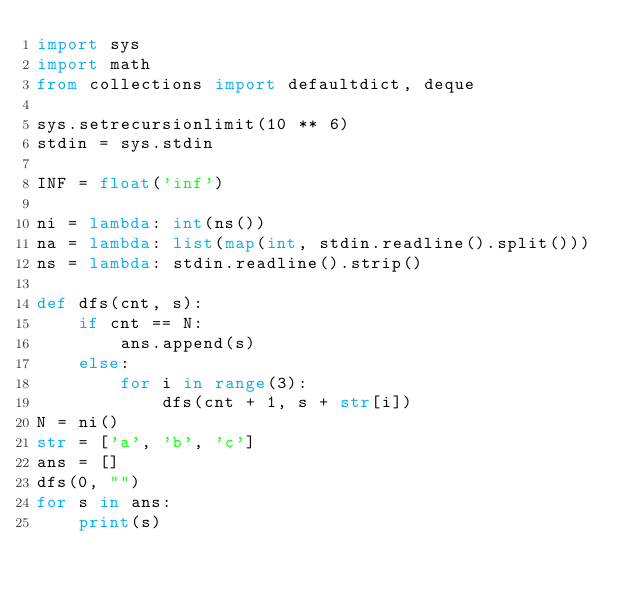Convert code to text. <code><loc_0><loc_0><loc_500><loc_500><_Python_>import sys
import math
from collections import defaultdict, deque

sys.setrecursionlimit(10 ** 6)
stdin = sys.stdin

INF = float('inf')

ni = lambda: int(ns())
na = lambda: list(map(int, stdin.readline().split()))
ns = lambda: stdin.readline().strip()

def dfs(cnt, s):
    if cnt == N:
        ans.append(s)
    else:
        for i in range(3):
            dfs(cnt + 1, s + str[i])
N = ni()
str = ['a', 'b', 'c']
ans = []
dfs(0, "")
for s in ans:
    print(s)</code> 